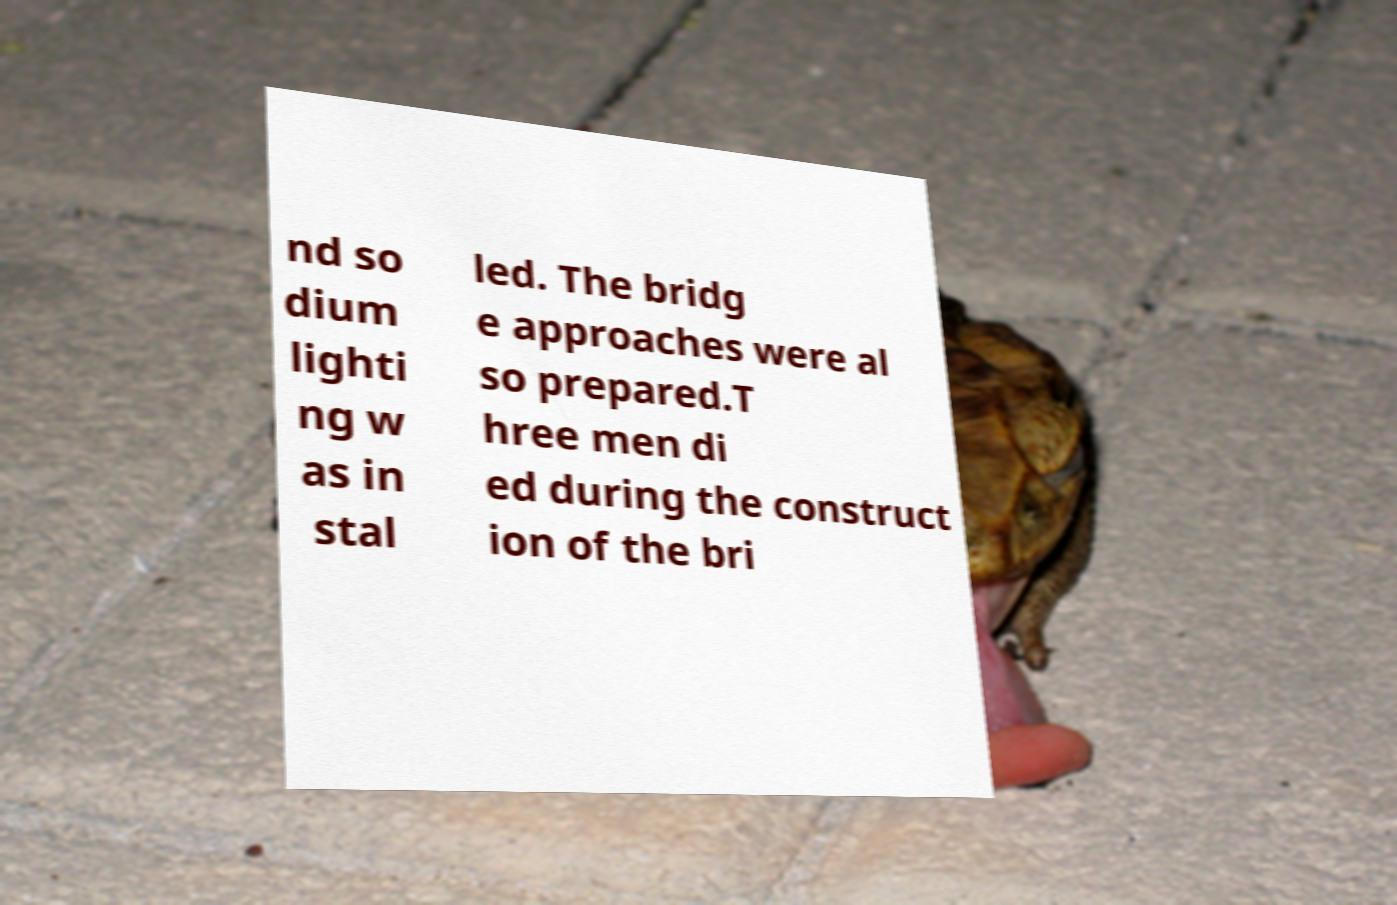Can you read and provide the text displayed in the image?This photo seems to have some interesting text. Can you extract and type it out for me? nd so dium lighti ng w as in stal led. The bridg e approaches were al so prepared.T hree men di ed during the construct ion of the bri 